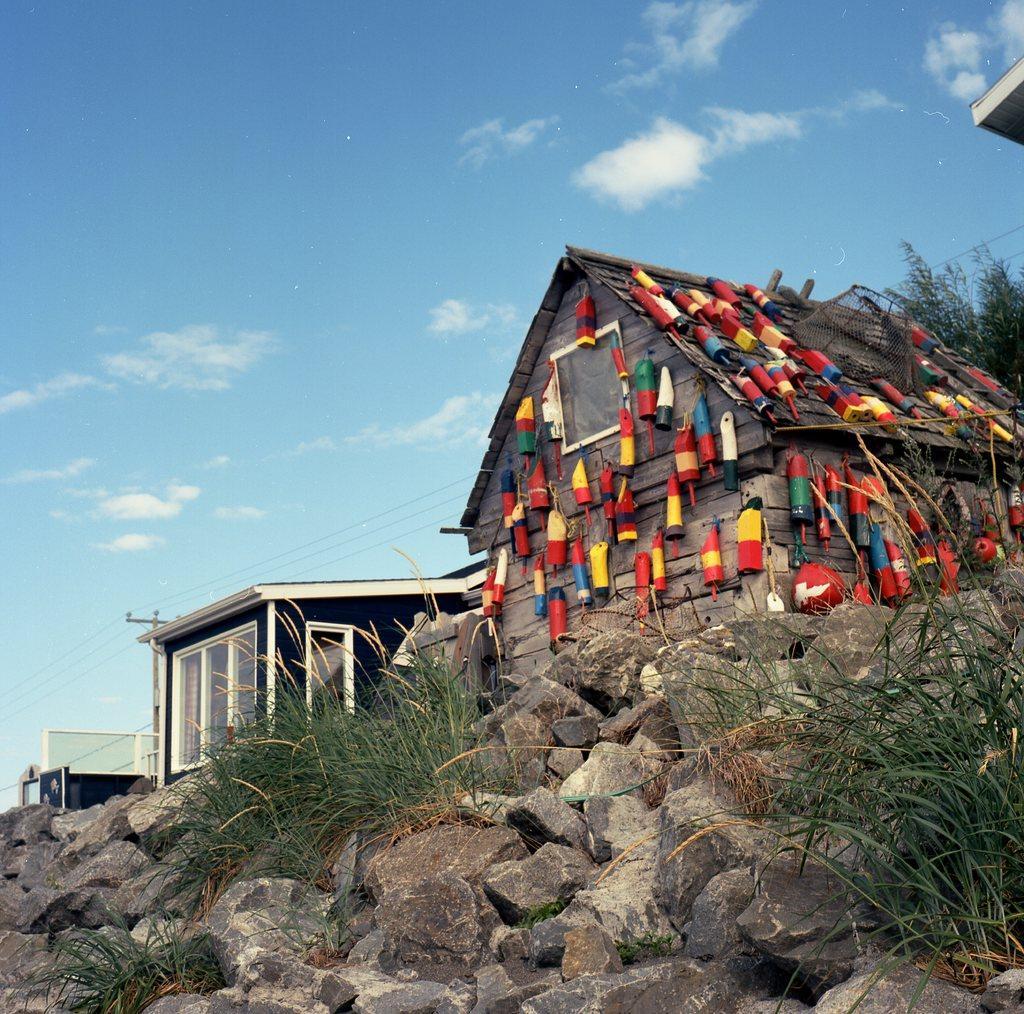Could you give a brief overview of what you see in this image? Here we can see stones and grass. In the background there are buildings,electric poles,wires and on the right there are some objects on a house and we can also see tree and clouds in the sky. 